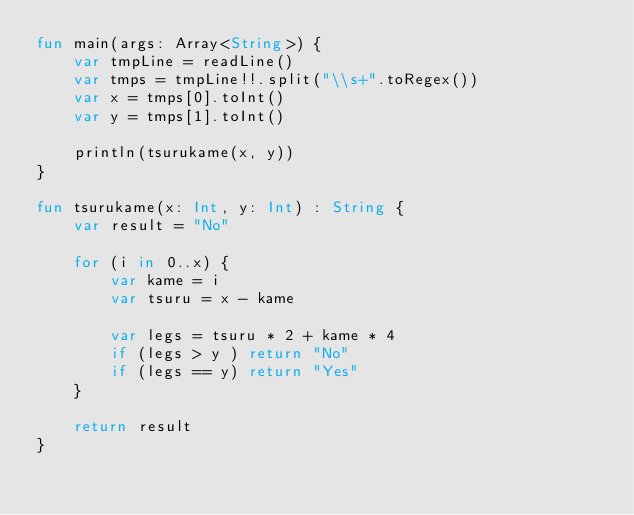<code> <loc_0><loc_0><loc_500><loc_500><_Kotlin_>fun main(args: Array<String>) {
    var tmpLine = readLine()
    var tmps = tmpLine!!.split("\\s+".toRegex())
    var x = tmps[0].toInt() 
    var y = tmps[1].toInt() 

    println(tsurukame(x, y))
}

fun tsurukame(x: Int, y: Int) : String {
    var result = "No"

    for (i in 0..x) {
        var kame = i 
        var tsuru = x - kame

        var legs = tsuru * 2 + kame * 4
        if (legs > y ) return "No"
        if (legs == y) return "Yes"
    }

    return result
}</code> 